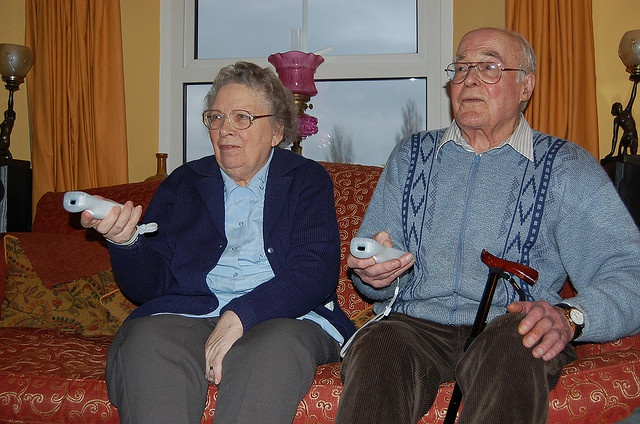Describe the objects in this image and their specific colors. I can see people in olive, black, and gray tones, people in olive, black, gray, navy, and lightblue tones, couch in olive, maroon, and brown tones, remote in olive, darkgray, and lightgray tones, and remote in olive, darkgray, and lightgray tones in this image. 